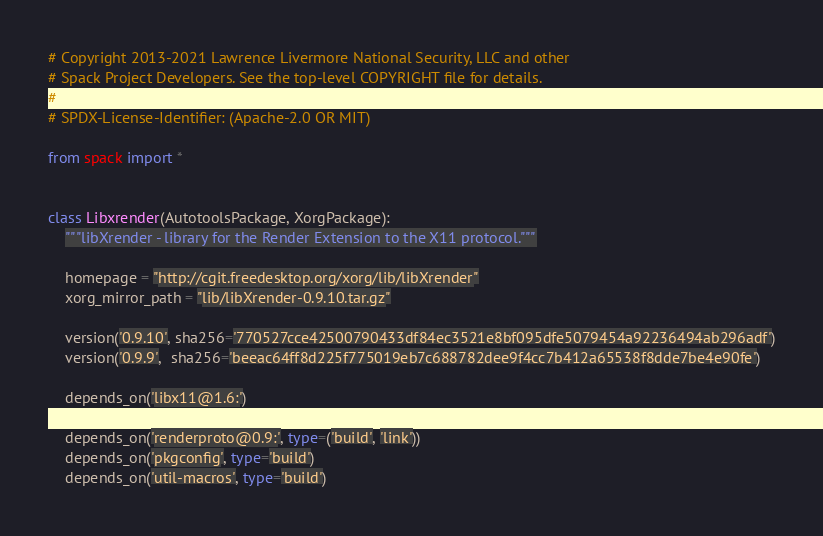Convert code to text. <code><loc_0><loc_0><loc_500><loc_500><_Python_># Copyright 2013-2021 Lawrence Livermore National Security, LLC and other
# Spack Project Developers. See the top-level COPYRIGHT file for details.
#
# SPDX-License-Identifier: (Apache-2.0 OR MIT)

from spack import *


class Libxrender(AutotoolsPackage, XorgPackage):
    """libXrender - library for the Render Extension to the X11 protocol."""

    homepage = "http://cgit.freedesktop.org/xorg/lib/libXrender"
    xorg_mirror_path = "lib/libXrender-0.9.10.tar.gz"

    version('0.9.10', sha256='770527cce42500790433df84ec3521e8bf095dfe5079454a92236494ab296adf')
    version('0.9.9',  sha256='beeac64ff8d225f775019eb7c688782dee9f4cc7b412a65538f8dde7be4e90fe')

    depends_on('libx11@1.6:')

    depends_on('renderproto@0.9:', type=('build', 'link'))
    depends_on('pkgconfig', type='build')
    depends_on('util-macros', type='build')
</code> 